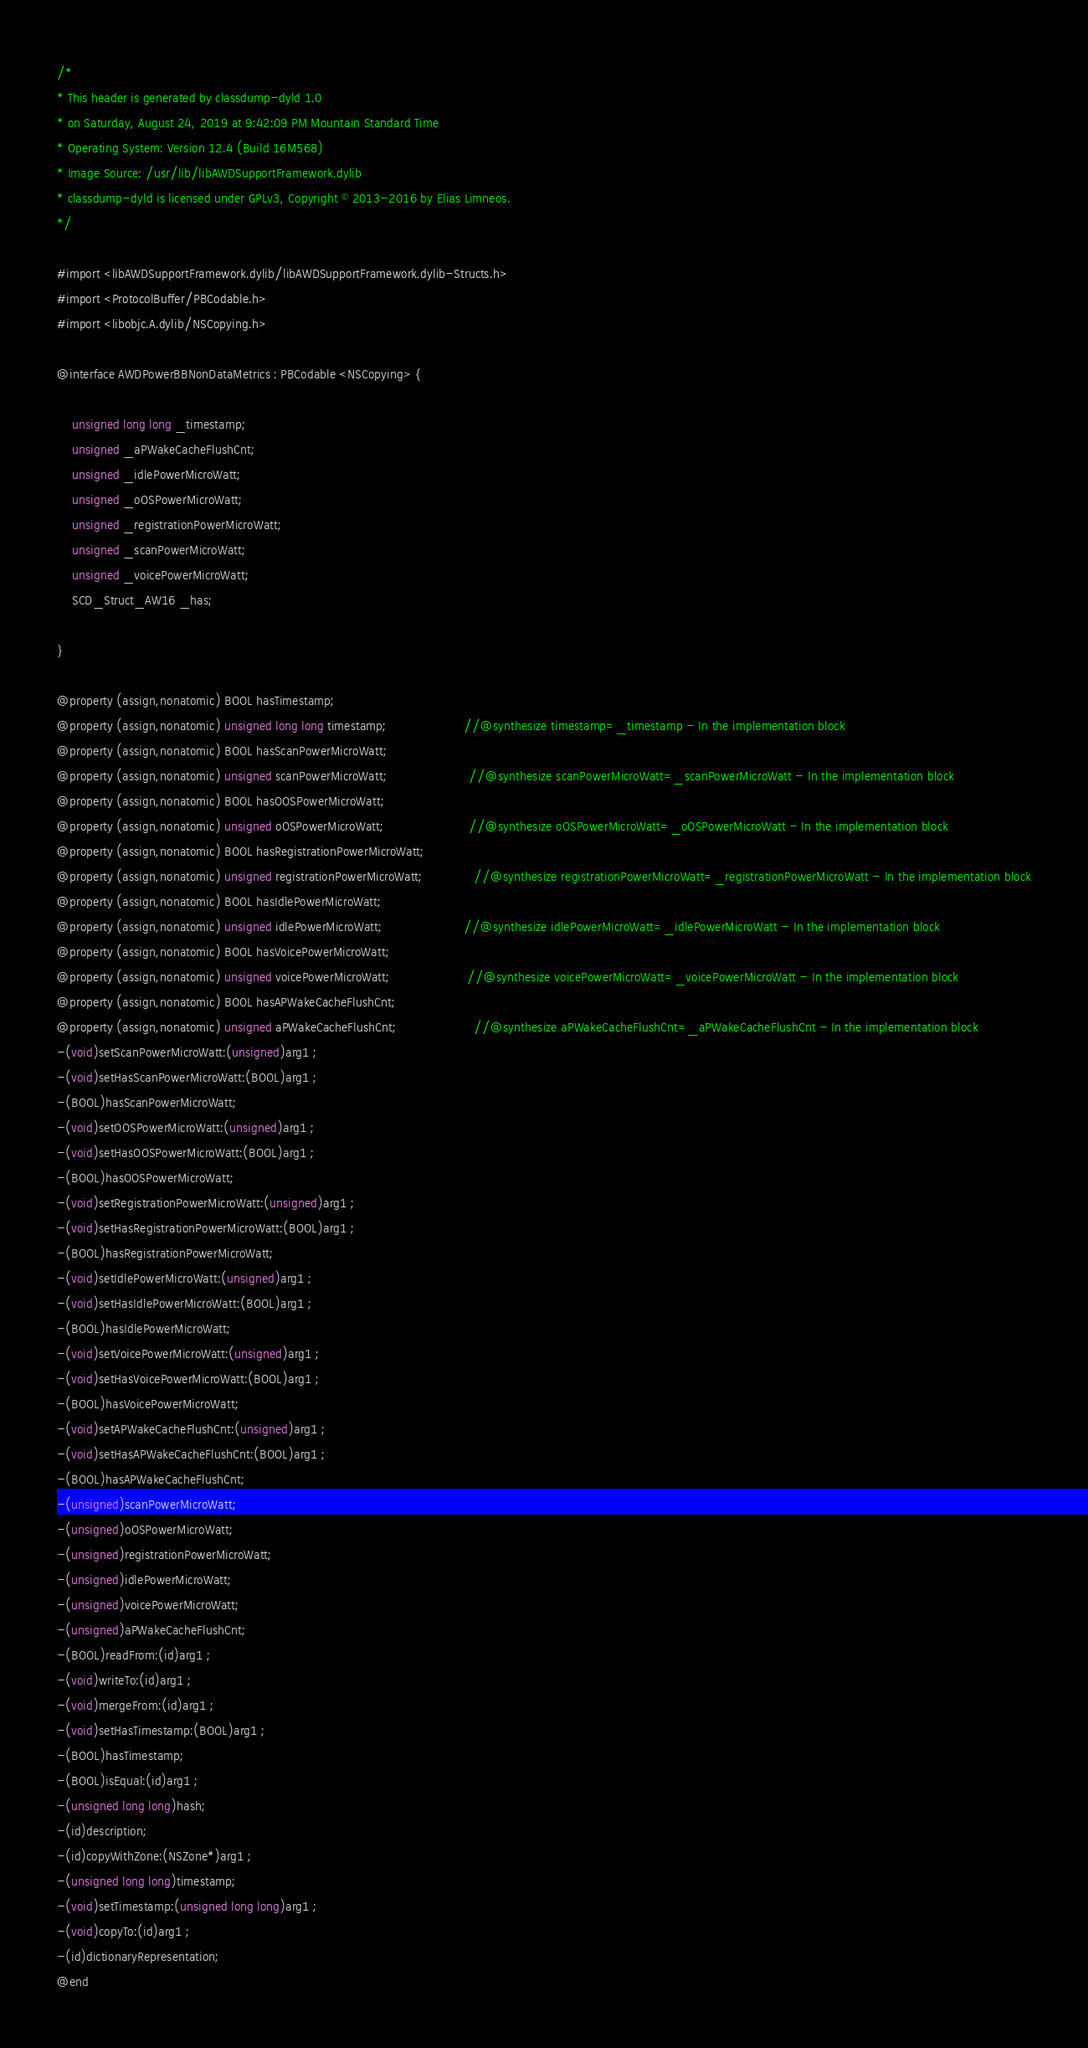<code> <loc_0><loc_0><loc_500><loc_500><_C_>/*
* This header is generated by classdump-dyld 1.0
* on Saturday, August 24, 2019 at 9:42:09 PM Mountain Standard Time
* Operating System: Version 12.4 (Build 16M568)
* Image Source: /usr/lib/libAWDSupportFramework.dylib
* classdump-dyld is licensed under GPLv3, Copyright © 2013-2016 by Elias Limneos.
*/

#import <libAWDSupportFramework.dylib/libAWDSupportFramework.dylib-Structs.h>
#import <ProtocolBuffer/PBCodable.h>
#import <libobjc.A.dylib/NSCopying.h>

@interface AWDPowerBBNonDataMetrics : PBCodable <NSCopying> {

	unsigned long long _timestamp;
	unsigned _aPWakeCacheFlushCnt;
	unsigned _idlePowerMicroWatt;
	unsigned _oOSPowerMicroWatt;
	unsigned _registrationPowerMicroWatt;
	unsigned _scanPowerMicroWatt;
	unsigned _voicePowerMicroWatt;
	SCD_Struct_AW16 _has;

}

@property (assign,nonatomic) BOOL hasTimestamp; 
@property (assign,nonatomic) unsigned long long timestamp;                     //@synthesize timestamp=_timestamp - In the implementation block
@property (assign,nonatomic) BOOL hasScanPowerMicroWatt; 
@property (assign,nonatomic) unsigned scanPowerMicroWatt;                      //@synthesize scanPowerMicroWatt=_scanPowerMicroWatt - In the implementation block
@property (assign,nonatomic) BOOL hasOOSPowerMicroWatt; 
@property (assign,nonatomic) unsigned oOSPowerMicroWatt;                       //@synthesize oOSPowerMicroWatt=_oOSPowerMicroWatt - In the implementation block
@property (assign,nonatomic) BOOL hasRegistrationPowerMicroWatt; 
@property (assign,nonatomic) unsigned registrationPowerMicroWatt;              //@synthesize registrationPowerMicroWatt=_registrationPowerMicroWatt - In the implementation block
@property (assign,nonatomic) BOOL hasIdlePowerMicroWatt; 
@property (assign,nonatomic) unsigned idlePowerMicroWatt;                      //@synthesize idlePowerMicroWatt=_idlePowerMicroWatt - In the implementation block
@property (assign,nonatomic) BOOL hasVoicePowerMicroWatt; 
@property (assign,nonatomic) unsigned voicePowerMicroWatt;                     //@synthesize voicePowerMicroWatt=_voicePowerMicroWatt - In the implementation block
@property (assign,nonatomic) BOOL hasAPWakeCacheFlushCnt; 
@property (assign,nonatomic) unsigned aPWakeCacheFlushCnt;                     //@synthesize aPWakeCacheFlushCnt=_aPWakeCacheFlushCnt - In the implementation block
-(void)setScanPowerMicroWatt:(unsigned)arg1 ;
-(void)setHasScanPowerMicroWatt:(BOOL)arg1 ;
-(BOOL)hasScanPowerMicroWatt;
-(void)setOOSPowerMicroWatt:(unsigned)arg1 ;
-(void)setHasOOSPowerMicroWatt:(BOOL)arg1 ;
-(BOOL)hasOOSPowerMicroWatt;
-(void)setRegistrationPowerMicroWatt:(unsigned)arg1 ;
-(void)setHasRegistrationPowerMicroWatt:(BOOL)arg1 ;
-(BOOL)hasRegistrationPowerMicroWatt;
-(void)setIdlePowerMicroWatt:(unsigned)arg1 ;
-(void)setHasIdlePowerMicroWatt:(BOOL)arg1 ;
-(BOOL)hasIdlePowerMicroWatt;
-(void)setVoicePowerMicroWatt:(unsigned)arg1 ;
-(void)setHasVoicePowerMicroWatt:(BOOL)arg1 ;
-(BOOL)hasVoicePowerMicroWatt;
-(void)setAPWakeCacheFlushCnt:(unsigned)arg1 ;
-(void)setHasAPWakeCacheFlushCnt:(BOOL)arg1 ;
-(BOOL)hasAPWakeCacheFlushCnt;
-(unsigned)scanPowerMicroWatt;
-(unsigned)oOSPowerMicroWatt;
-(unsigned)registrationPowerMicroWatt;
-(unsigned)idlePowerMicroWatt;
-(unsigned)voicePowerMicroWatt;
-(unsigned)aPWakeCacheFlushCnt;
-(BOOL)readFrom:(id)arg1 ;
-(void)writeTo:(id)arg1 ;
-(void)mergeFrom:(id)arg1 ;
-(void)setHasTimestamp:(BOOL)arg1 ;
-(BOOL)hasTimestamp;
-(BOOL)isEqual:(id)arg1 ;
-(unsigned long long)hash;
-(id)description;
-(id)copyWithZone:(NSZone*)arg1 ;
-(unsigned long long)timestamp;
-(void)setTimestamp:(unsigned long long)arg1 ;
-(void)copyTo:(id)arg1 ;
-(id)dictionaryRepresentation;
@end

</code> 